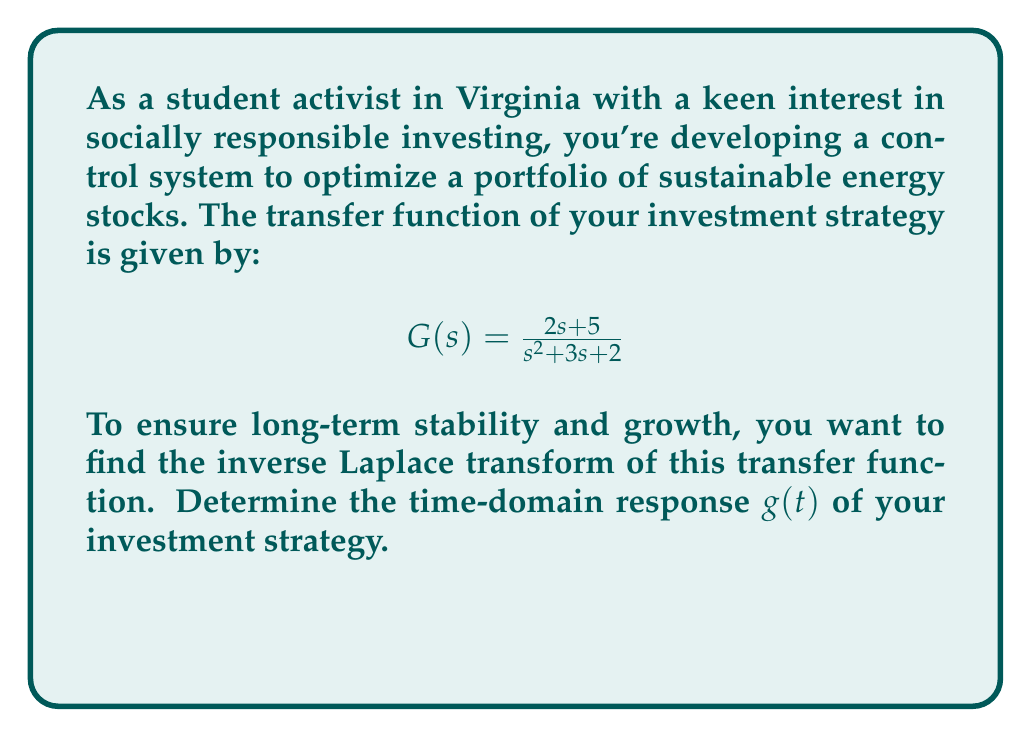Can you answer this question? Let's approach this step-by-step:

1) We start with the transfer function:
   $$G(s) = \frac{2s + 5}{s^2 + 3s + 2}$$

2) To find the inverse Laplace transform, we need to factor the denominator:
   $$s^2 + 3s + 2 = (s+1)(s+2)$$

3) Now we can use partial fraction decomposition:
   $$\frac{2s + 5}{(s+1)(s+2)} = \frac{A}{s+1} + \frac{B}{s+2}$$

4) Solve for A and B:
   $2s + 5 = A(s+2) + B(s+1)$
   $2s + 5 = (A+B)s + (2A+B)$
   
   Comparing coefficients:
   $2 = A+B$
   $5 = 2A+B$
   
   Solving these equations:
   $A = 3, B = -1$

5) So, we have:
   $$G(s) = \frac{3}{s+1} - \frac{1}{s+2}$$

6) Now we can use the inverse Laplace transform:
   $\mathcal{L}^{-1}\{\frac{1}{s+a}\} = e^{-at}$

7) Therefore:
   $$g(t) = 3e^{-t} - e^{-2t}$$

This is the time-domain response of the investment strategy.
Answer: $g(t) = 3e^{-t} - e^{-2t}$ 